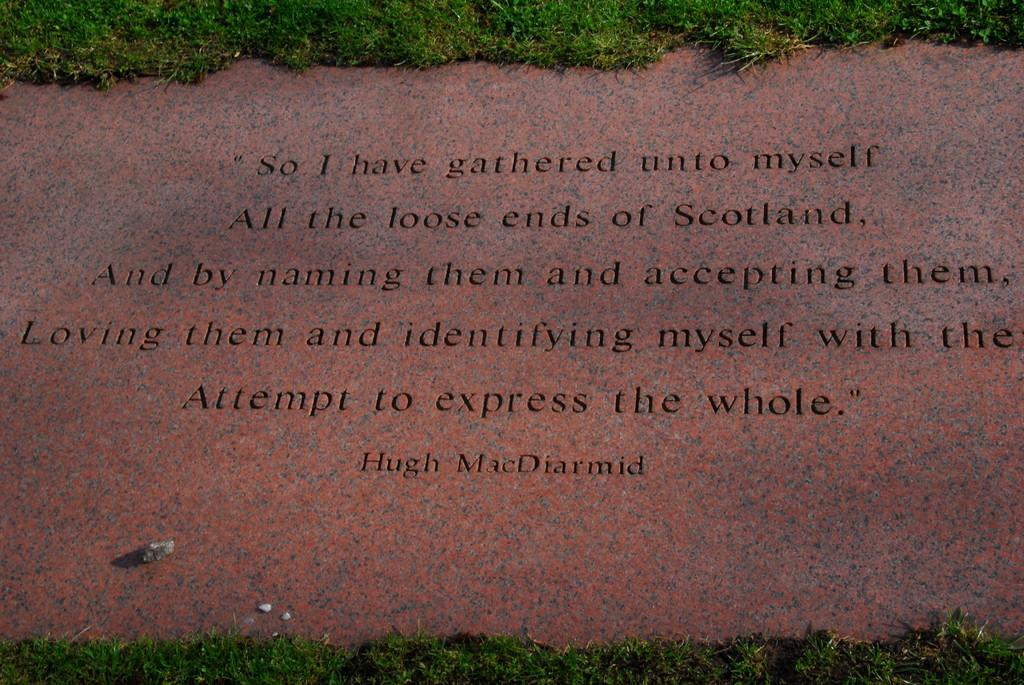What is written on the marble floor in the image? There is a quotation on the marble floor in the image. What type of surface is the quotation written on? The quotation is written on a marble floor. What can be seen surrounding the marble floor in the image? There is grass surrounding the marble floor in the image. Where is the ice located in the image? There is no ice present in the image. What type of harbor can be seen in the image? There is no harbor present in the image. 